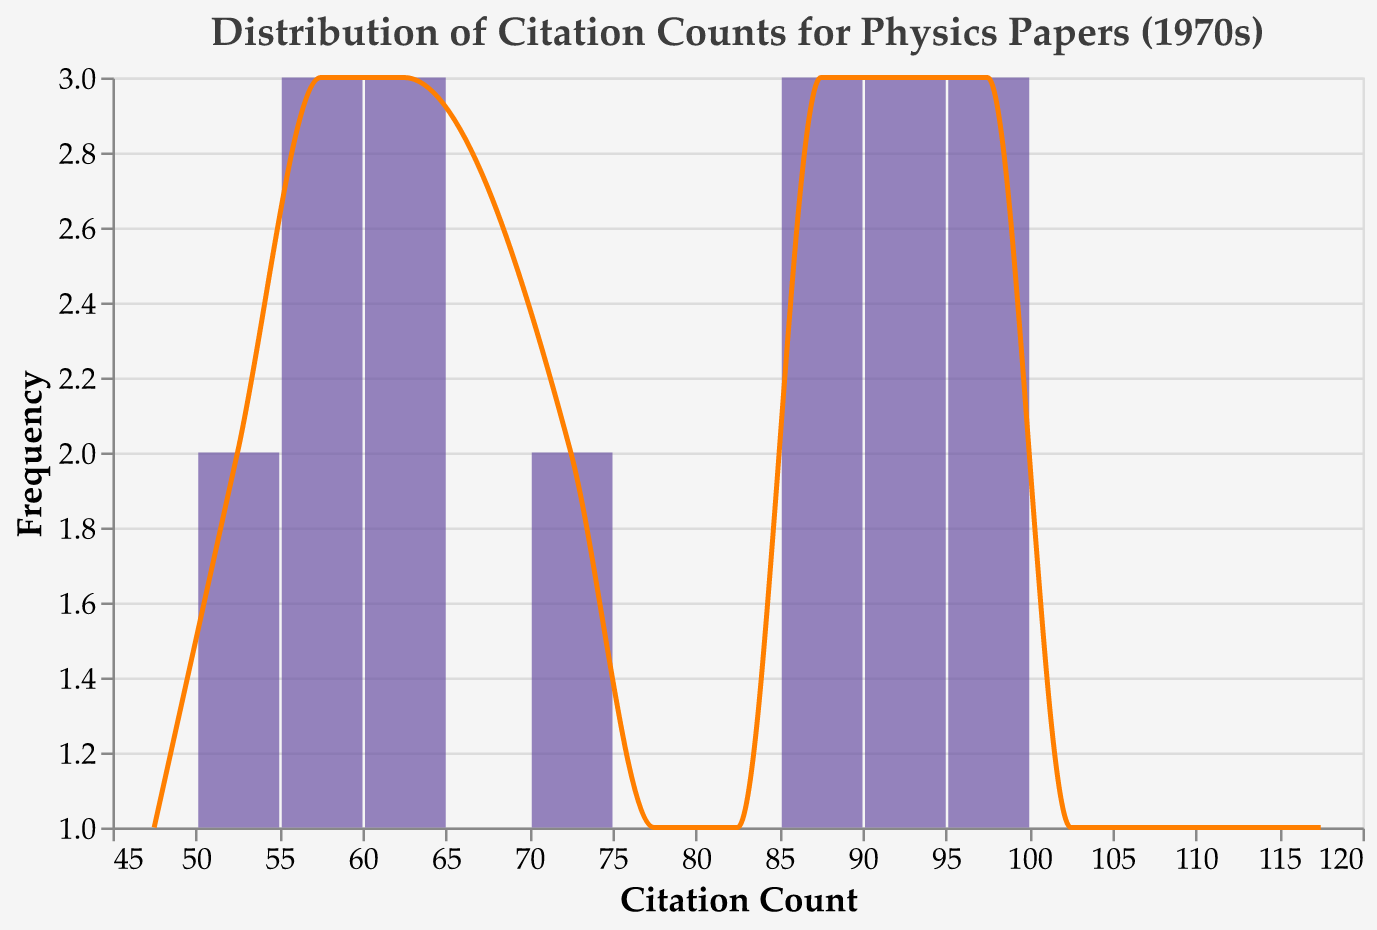What is the title of the figure? The title of the figure is displayed at the top of the plot. It reads "Distribution of Citation Counts for Physics Papers (1970s)".
Answer: Distribution of Citation Counts for Physics Papers (1970s) What is the range of the x-axis? The x-axis represents the "Citation Count" and starts from a minimum of 40 and extends to a maximum of 130.
Answer: 40 to 130 What color is used for the bars in the plot? The bars in the plot are colored in a shade of purple.
Answer: Purple How many citation count bins are there in the plot? The x-axis is divided into bins. By examining the plot, one can see that the citation counts are grouped into 15 bins.
Answer: 15 What is the most frequent citation count interval? The height of the bars represents the frequency. The tallest bar corresponds to the citation count interval with the highest frequency.
Answer: 50-60 How many papers have citation counts between 80 and 100? By examining the bins between 80 and 100, we count the heights of the bars in this range. There are four bars representing papers in the citation count intervals 80-90, 90-100. By checking the heights, we see that they total to a count of 6 papers.
Answer: 6 What's the average citation count for the papers in the plot? To find the average citation count, sum all the citation counts and divide by the number of papers. Total Citation Counts: 2106 (Sum of all citation counts). Number of Papers: 26. Average = 2106 / 26 = 81
Answer: 81 How does the count of papers with citation ranges of 40-50 compare to the count of papers with citation ranges of 100-110? Count the heights of the bars in the 40-50 range and compare them with the heights of the bars in the 100-110 range. The 40-50 range has fewer bars compared to the 100-110 range.
Answer: 40-50 < 100-110 What is the median citation count of the dataset? To determine the median citation count, first list all citation counts in ascending order and find the middle value. For 26 data points, the median will be the average of the 13th and 14th values: Median of (64, 71, 74, 78, 83, 85, 87, 88, 90, 92, 93, 97, 98, 99): = (83 + 85) / 2 = 84
Answer: 84 